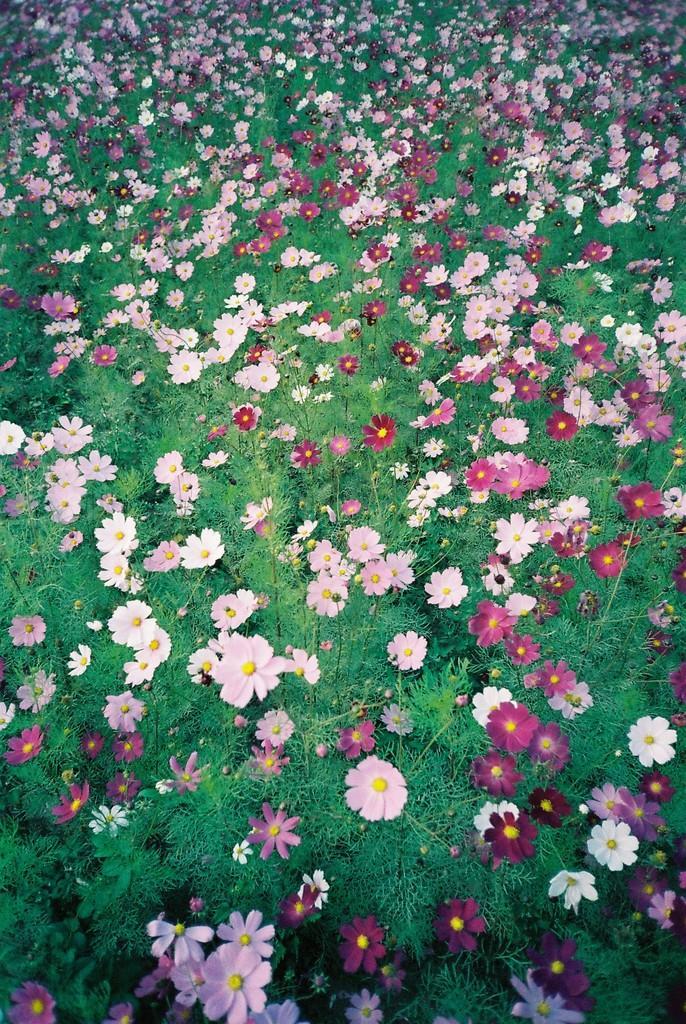Describe this image in one or two sentences. In the picture we can see, full of plants with flowers to it which are pink in color and some are light pink in color. 